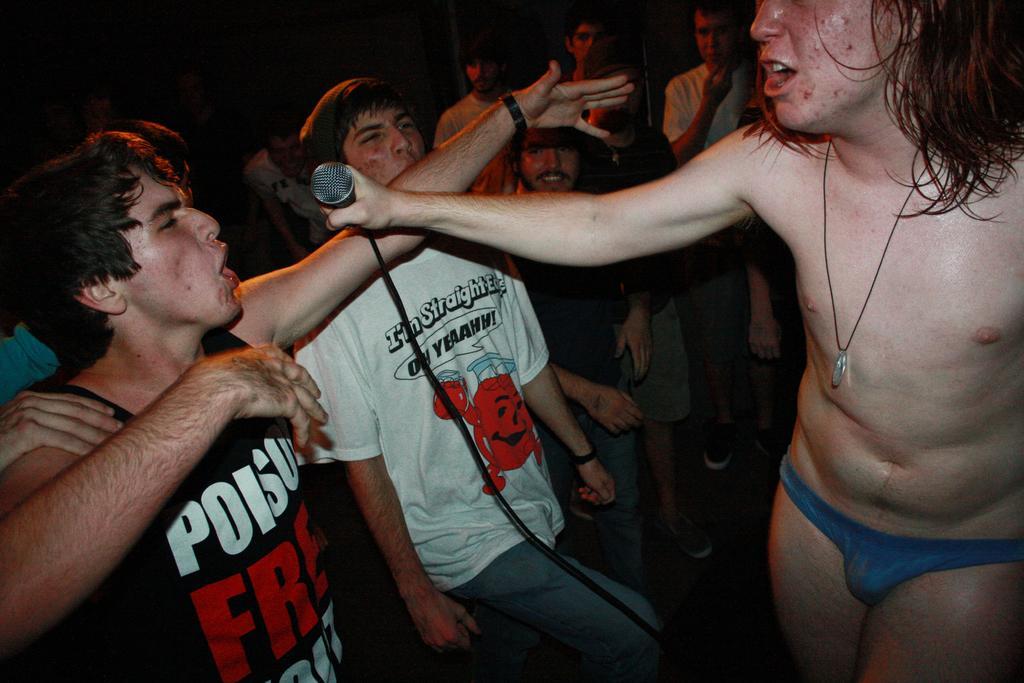Can you describe this image briefly? In this image we can see a group of people standing. One person is holding a microphone with cable in his hand. 